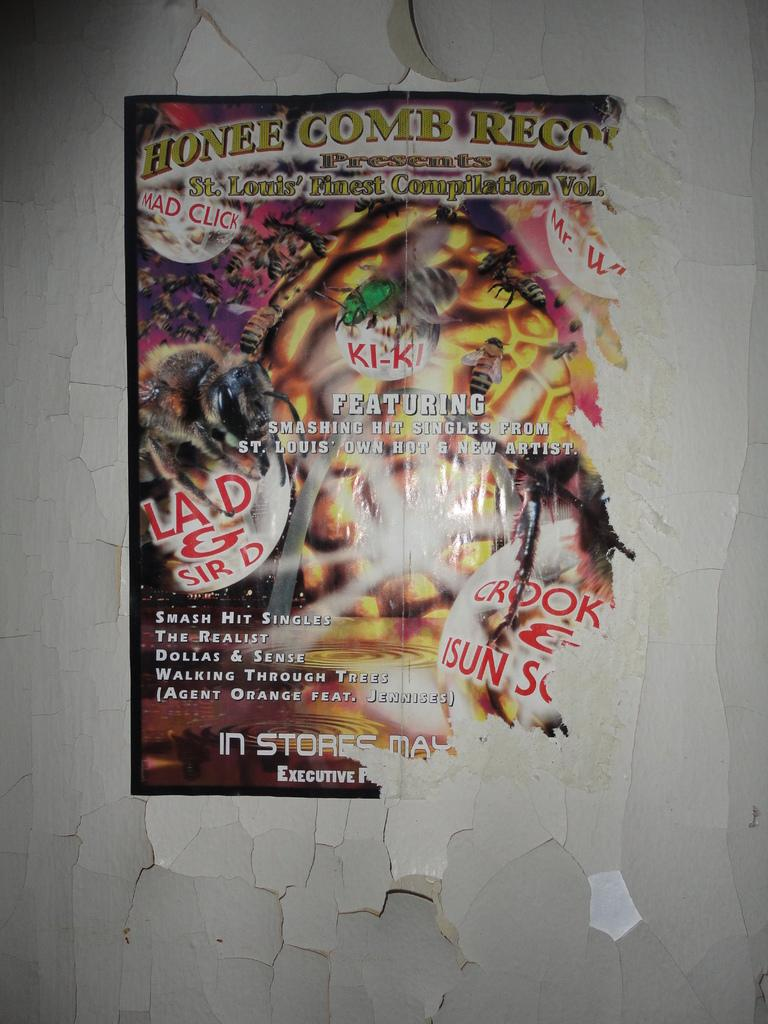Provide a one-sentence caption for the provided image. A poster hung on a crumbling wall advertises Honee Comb Records, Featuring smashing singles from St. Louis' Own Hot and New Artist. 